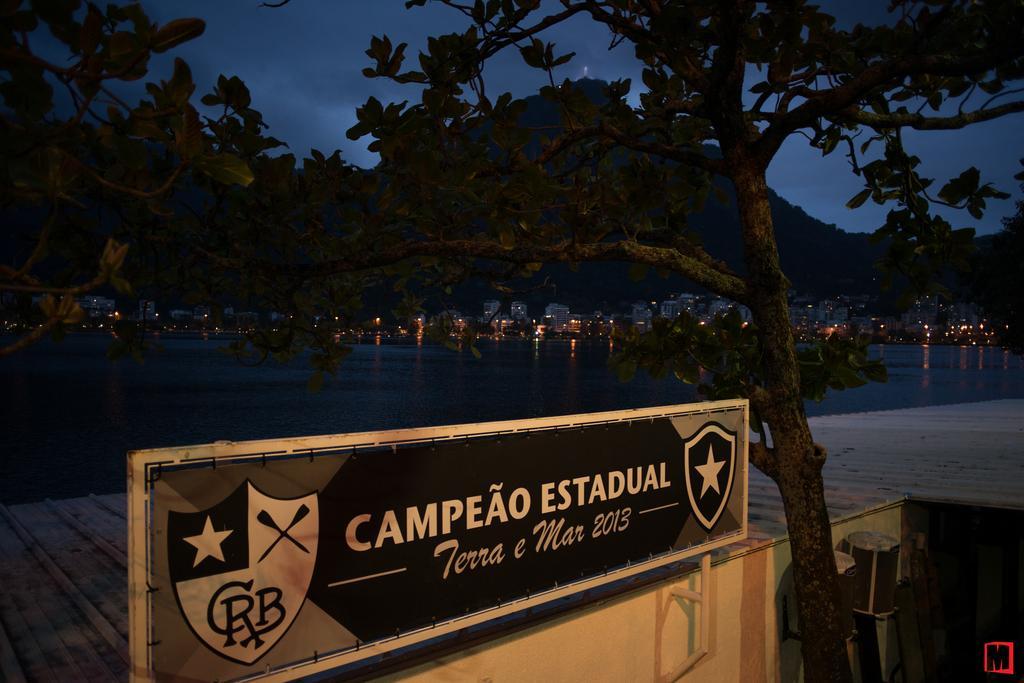Can you describe this image briefly? In this image we can see sky with clouds, hills, trees, buildings, walkway bridge and a name board. 